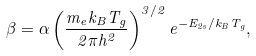<formula> <loc_0><loc_0><loc_500><loc_500>\beta = \alpha \left ( \frac { m _ { e } k _ { B } T _ { g } } { 2 \pi h ^ { 2 } } \right ) ^ { 3 / 2 } e ^ { - E _ { 2 s } / k _ { B } T _ { g } } ,</formula> 